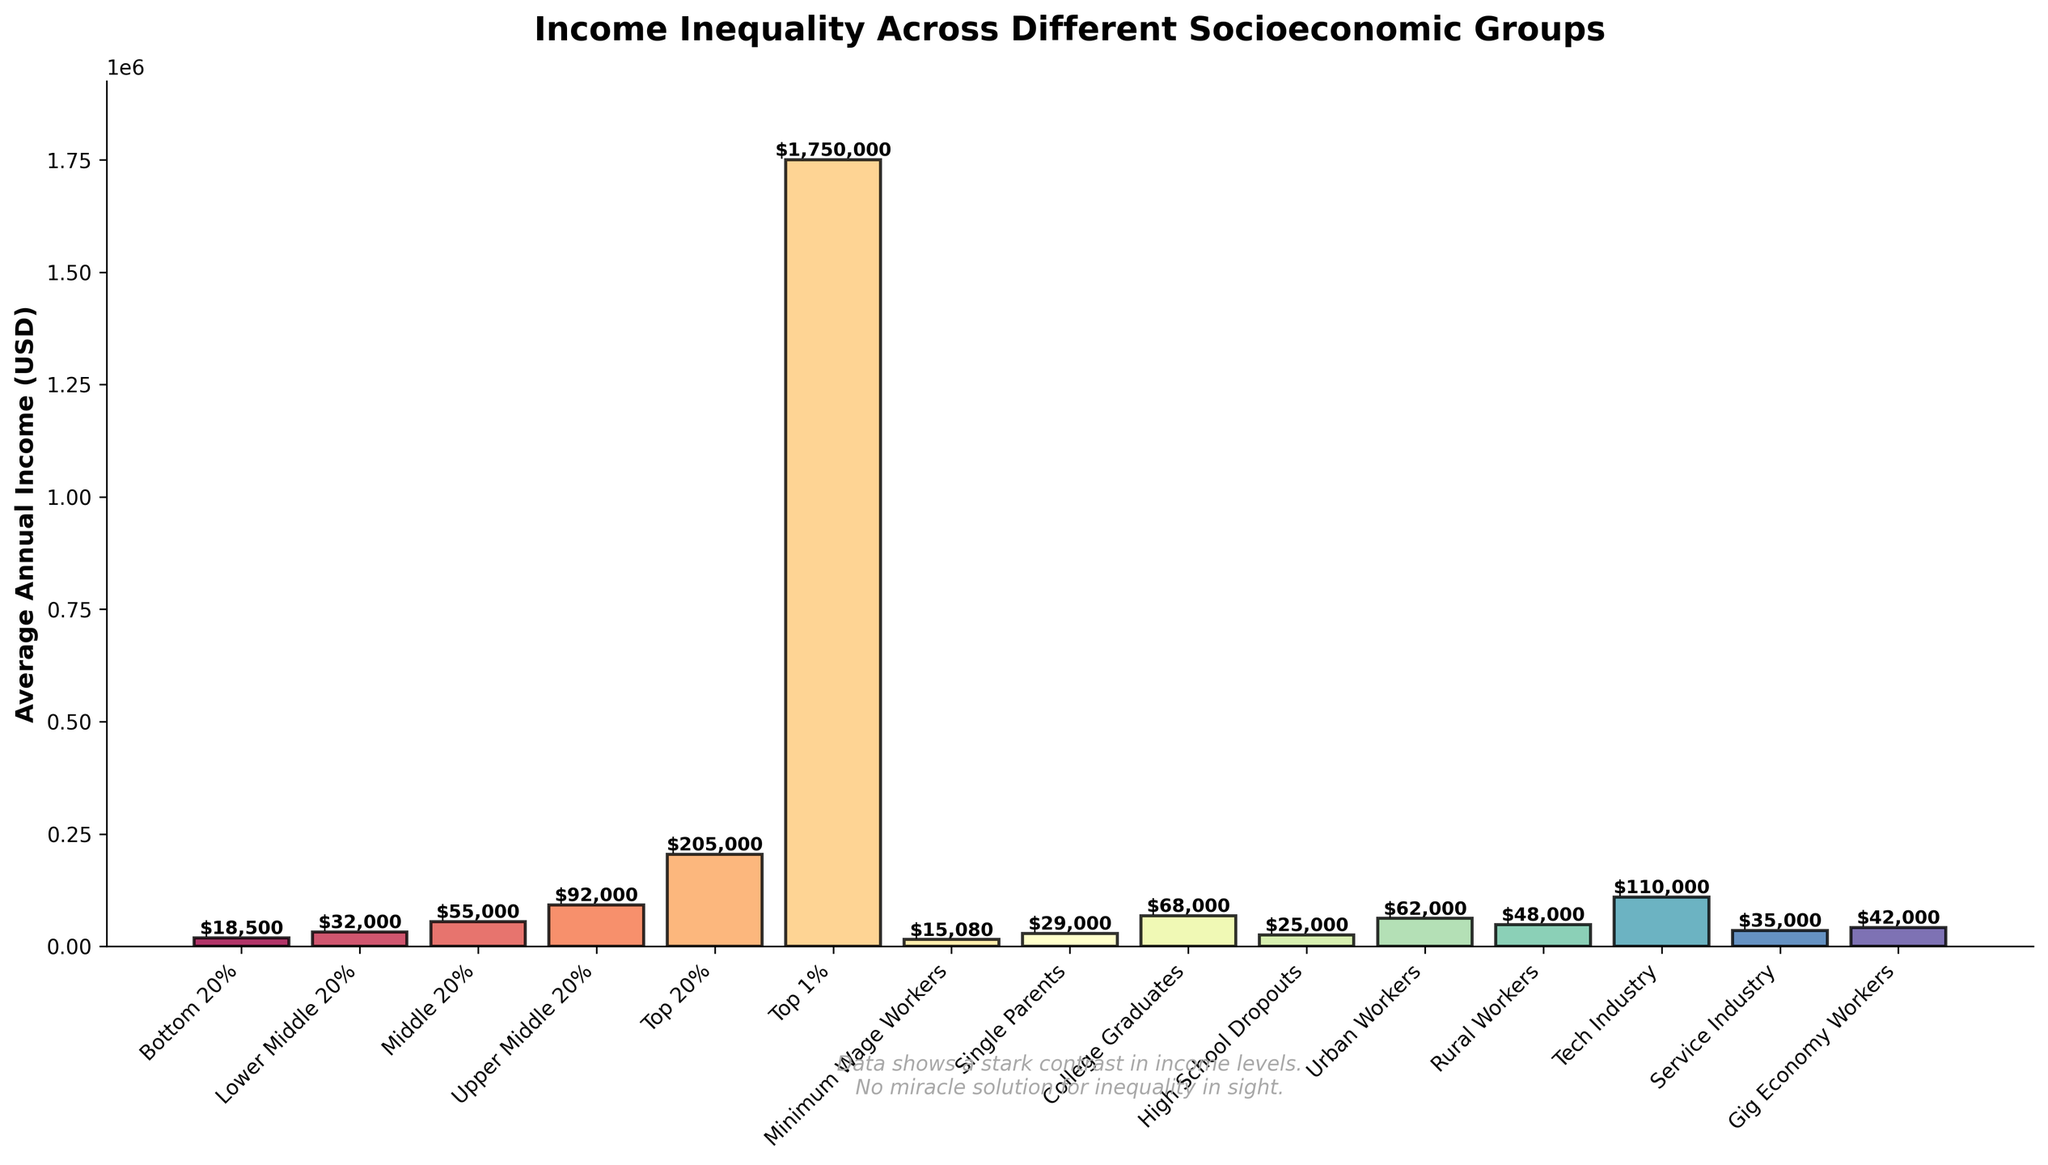Which income group has the highest average annual income? The Top 1% income group has the highest bar on the plot, indicating the highest average annual income.
Answer: Top 1% Which three groups have the lowest average annual income? The Minimum Wage Workers, High School Dropouts, and Bottom 20% have the shortest bars, indicating they have the lowest average annual incomes.
Answer: Minimum Wage Workers, High School Dropouts, Bottom 20% How much more do College Graduates earn on average compared to High School Dropouts? Locate the average annual incomes for College Graduates and High School Dropouts. College Graduates earn $68,000, and High School Dropouts earn $25,000. The difference is $68,000 - $25,000 = $43,000.
Answer: $43,000 What is the total average income of the Top 20% and the Upper Middle 20% groups combined? Locate the average annual incomes for the Top 20% and the Upper Middle 20%. Top 20% earns $205,000, and Upper Middle 20% earns $92,000. The combined income is $205,000 + $92,000 = $297,000.
Answer: $297,000 Which group has a higher average annual income: Rural Workers or Service Industry workers? By comparing the heights of the bars or their labeled incomes, Rural Workers earn $48,000, whereas the Service Industry earns $35,000.
Answer: Rural Workers Is the average income of Urban Workers closer to College Graduates or Tech Industry workers? Urban Workers earn $62,000, College Graduates earn $68,000, and Tech Industry workers earn $110,000. The difference between Urban Workers and College Graduates is $6,000, whereas with Tech Industry workers, it is $48,000.
Answer: College Graduates Which category has an average income just below Single Parents? Single Parents have an average annual income of $29,000. The category with the next lowest income is Service Industry at $35,000.
Answer: Service Industry How does the income of Gig Economy Workers compare to that of the Middle 20%? Gig Economy Workers earn $42,000, while the Middle 20% earn $55,000. Gig Economy Workers earn $13,000 less than the Middle 20%.
Answer: Gig Economy Workers earn less What is the difference in income between the Bottom 20% and the Top 20%? The Bottom 20% earn $18,500, and the Top 20% earn $205,000. The difference is $205,000 - $18,500 = $186,500.
Answer: $186,500 What visual elements highlight the disparity in income between the Top 1% and other groups? The bar for the Top 1% is significantly taller than all other bars, and its label of $1,750,000 starkly contrasts with other values on the chart.
Answer: Largest bar and highest label 